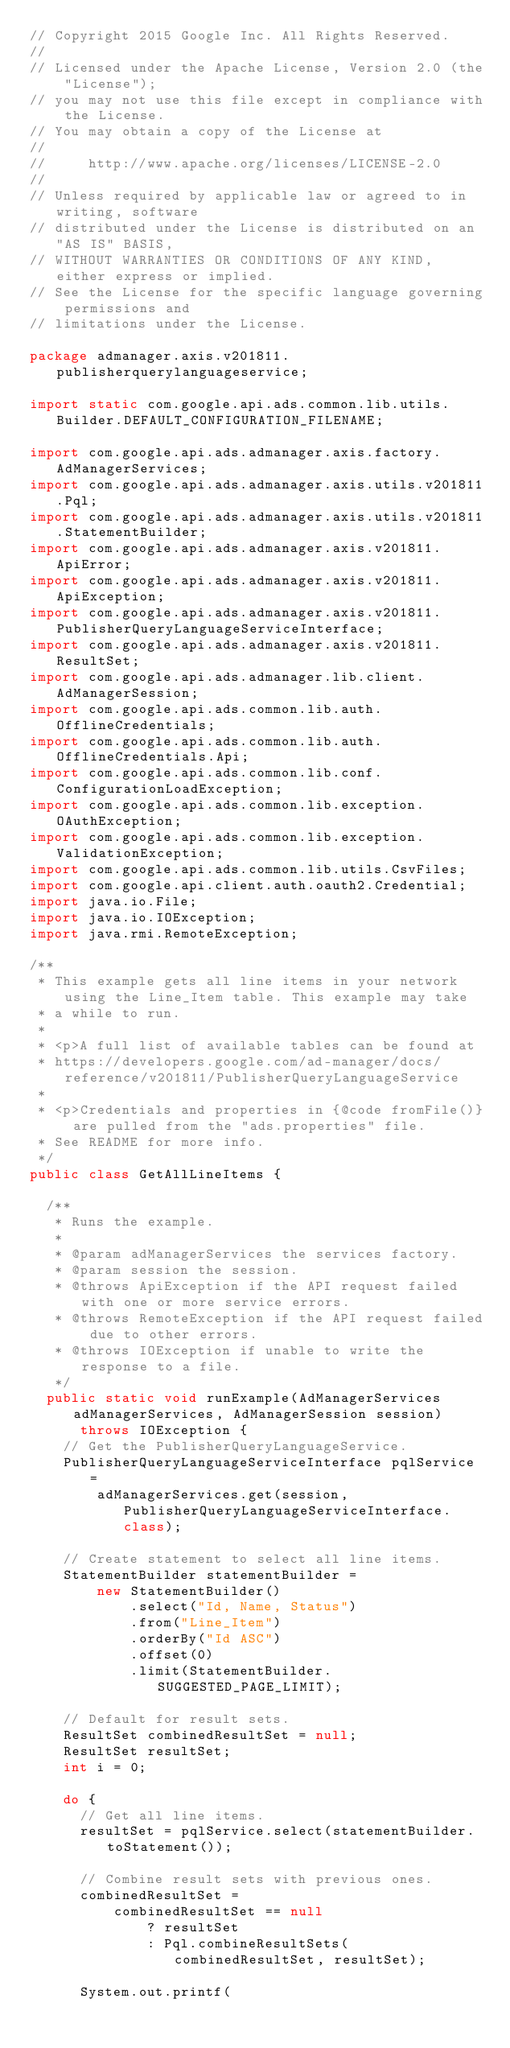Convert code to text. <code><loc_0><loc_0><loc_500><loc_500><_Java_>// Copyright 2015 Google Inc. All Rights Reserved.
//
// Licensed under the Apache License, Version 2.0 (the "License");
// you may not use this file except in compliance with the License.
// You may obtain a copy of the License at
//
//     http://www.apache.org/licenses/LICENSE-2.0
//
// Unless required by applicable law or agreed to in writing, software
// distributed under the License is distributed on an "AS IS" BASIS,
// WITHOUT WARRANTIES OR CONDITIONS OF ANY KIND, either express or implied.
// See the License for the specific language governing permissions and
// limitations under the License.

package admanager.axis.v201811.publisherquerylanguageservice;

import static com.google.api.ads.common.lib.utils.Builder.DEFAULT_CONFIGURATION_FILENAME;

import com.google.api.ads.admanager.axis.factory.AdManagerServices;
import com.google.api.ads.admanager.axis.utils.v201811.Pql;
import com.google.api.ads.admanager.axis.utils.v201811.StatementBuilder;
import com.google.api.ads.admanager.axis.v201811.ApiError;
import com.google.api.ads.admanager.axis.v201811.ApiException;
import com.google.api.ads.admanager.axis.v201811.PublisherQueryLanguageServiceInterface;
import com.google.api.ads.admanager.axis.v201811.ResultSet;
import com.google.api.ads.admanager.lib.client.AdManagerSession;
import com.google.api.ads.common.lib.auth.OfflineCredentials;
import com.google.api.ads.common.lib.auth.OfflineCredentials.Api;
import com.google.api.ads.common.lib.conf.ConfigurationLoadException;
import com.google.api.ads.common.lib.exception.OAuthException;
import com.google.api.ads.common.lib.exception.ValidationException;
import com.google.api.ads.common.lib.utils.CsvFiles;
import com.google.api.client.auth.oauth2.Credential;
import java.io.File;
import java.io.IOException;
import java.rmi.RemoteException;

/**
 * This example gets all line items in your network using the Line_Item table. This example may take
 * a while to run.
 *
 * <p>A full list of available tables can be found at
 * https://developers.google.com/ad-manager/docs/reference/v201811/PublisherQueryLanguageService
 *
 * <p>Credentials and properties in {@code fromFile()} are pulled from the "ads.properties" file.
 * See README for more info.
 */
public class GetAllLineItems {

  /**
   * Runs the example.
   *
   * @param adManagerServices the services factory.
   * @param session the session.
   * @throws ApiException if the API request failed with one or more service errors.
   * @throws RemoteException if the API request failed due to other errors.
   * @throws IOException if unable to write the response to a file.
   */
  public static void runExample(AdManagerServices adManagerServices, AdManagerSession session)
      throws IOException {
    // Get the PublisherQueryLanguageService.
    PublisherQueryLanguageServiceInterface pqlService =
        adManagerServices.get(session, PublisherQueryLanguageServiceInterface.class);

    // Create statement to select all line items.
    StatementBuilder statementBuilder =
        new StatementBuilder()
            .select("Id, Name, Status")
            .from("Line_Item")
            .orderBy("Id ASC")
            .offset(0)
            .limit(StatementBuilder.SUGGESTED_PAGE_LIMIT);

    // Default for result sets.
    ResultSet combinedResultSet = null;
    ResultSet resultSet;
    int i = 0;

    do {
      // Get all line items.
      resultSet = pqlService.select(statementBuilder.toStatement());

      // Combine result sets with previous ones.
      combinedResultSet =
          combinedResultSet == null
              ? resultSet
              : Pql.combineResultSets(combinedResultSet, resultSet);

      System.out.printf(</code> 